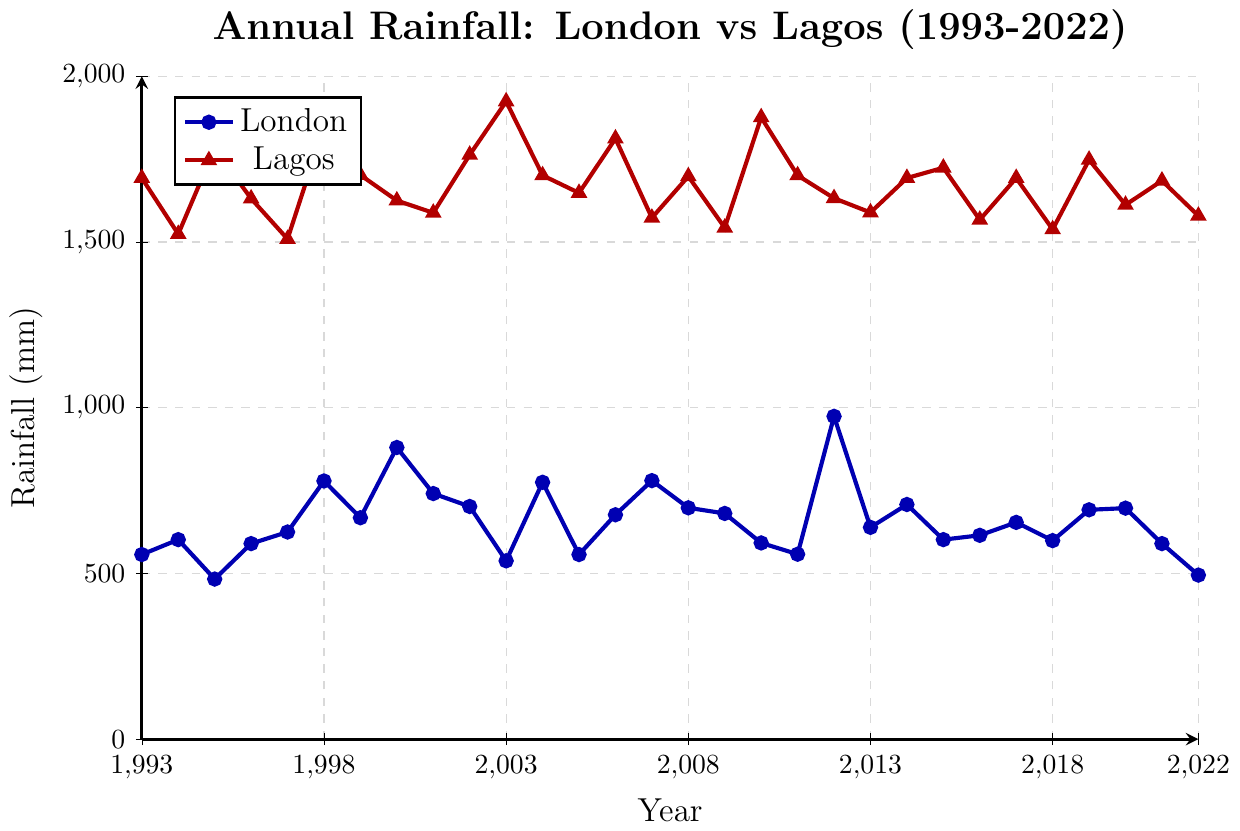Which year did London have the highest annual rainfall? Looking at the plot for the blue line representing London, the peak seems to be around 2012. Therefore, London had the highest annual rainfall in the year 2012.
Answer: 2012 How did the rainfall in Lagos and London compare in 2003? The plot shows that in 2003, the red line for Lagos is at 1924 mm while the blue line for London is at 538 mm. By comparing these values, Lagos had significantly more rainfall than London in 2003.
Answer: Lagos had significantly more rainfall What is the average rainfall in London over the 30 years? To find the average, sum up all the annual rainfall values for London and divide by 30. (557 + 602 + 483 + 590 + 625 + 779 + 668 + 880 + 741 + 702 + 538 + 775 + 557 + 677 + 780 + 698 + 681 + 592 + 558 + 974 + 639 + 708 + 602 + 615 + 654 + 599 + 692 + 697 + 590 + 495) / 30, which equals 663.7 mm.
Answer: 663.7 mm In which year did Lagos experience its highest annual rainfall? Reviewing the plot for the red line representing Lagos, it appears that the highest annual rainfall occurred around 2003 with a value of 1924 mm.
Answer: 2003 Which year had the smallest difference in rainfall between London and Lagos? To determine this, examine the plot for the years where the blue and red lines are closest to each other. Roughly, the closest proximity seems to be around 2011 where London had 558 mm and Lagos had 1701 mm. The difference is 1701 - 558 = 1143 mm.
Answer: 2011 By how much did London’s highest annual rainfall exceed its lowest? London’s highest annual rainfall is 974 mm in 2012 and its lowest is 483 mm in 1995. The difference is 974 - 483 = 491 mm.
Answer: 491 mm Which city had a larger variation in rainfall over the 30 years? Variation can be estimated by the range of values seen for each city. The highest and lowest for Lagos are 1924 mm and 1509 mm, respectively, so the range is 1924 - 1509 = 415 mm. The highest and lowest for London are 974 mm and 483 mm, respectively, so the range is 974 - 483 = 491 mm. London had the larger variation.
Answer: London How many years did Lagos have more than 1800 mm of rainfall? By observing the red line for Lagos, the years exceeding 1800 mm are 1995, 1998, 2003, 2006, 2010. Counting these, Lagos had more than 1800 mm of rainfall in 5 years.
Answer: 5 years 